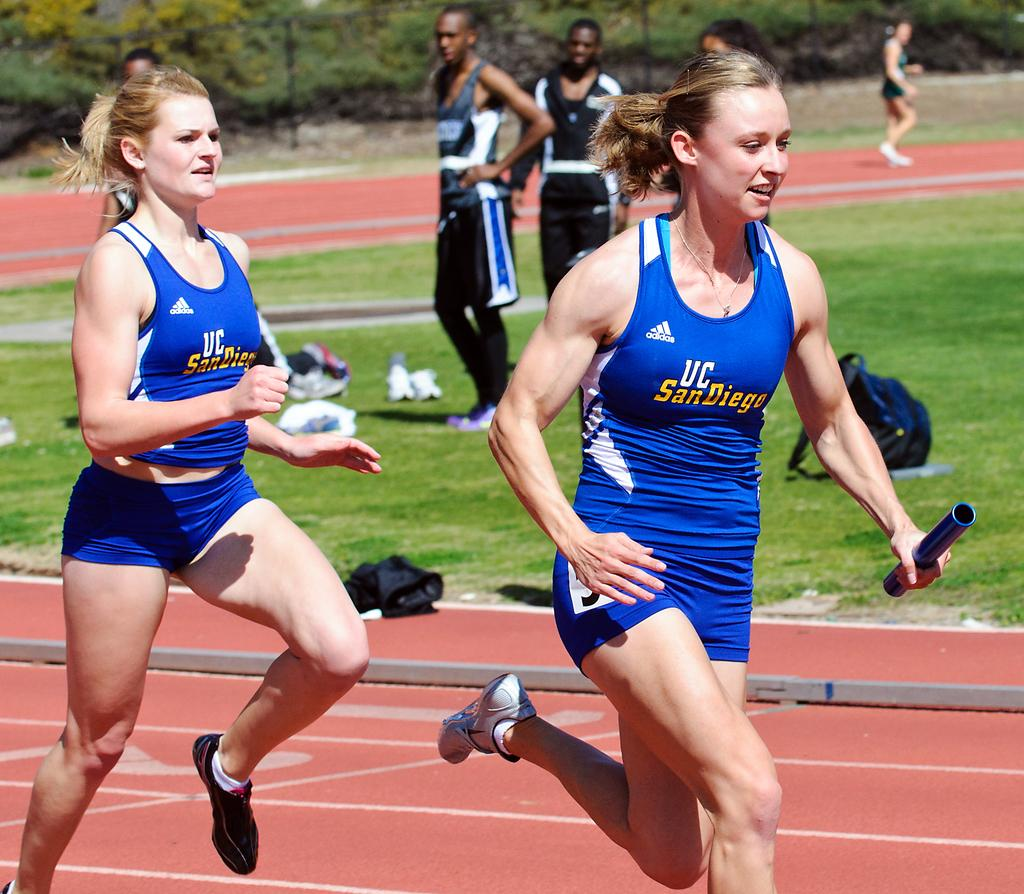<image>
Render a clear and concise summary of the photo. Girls are running on a track in tank tops with the adidas logo on them. 